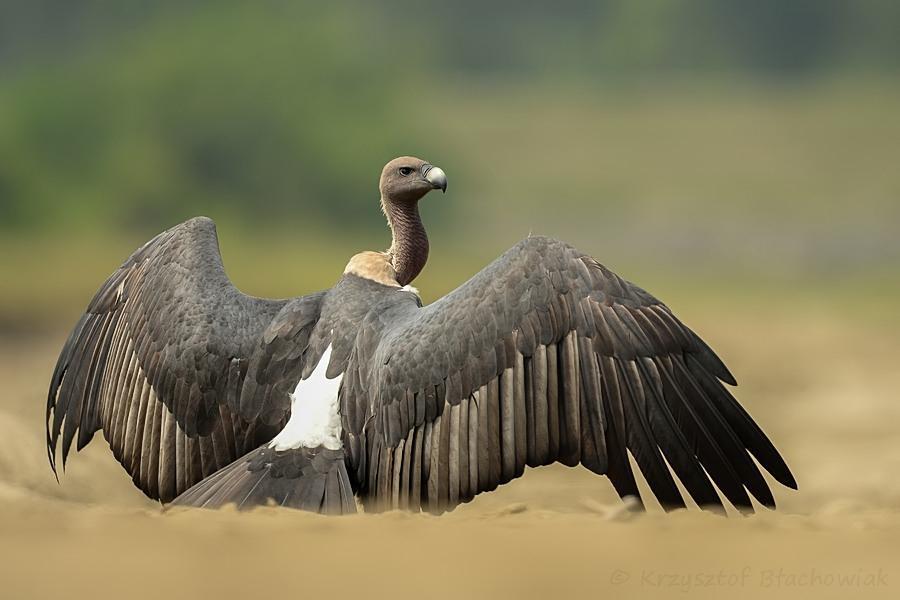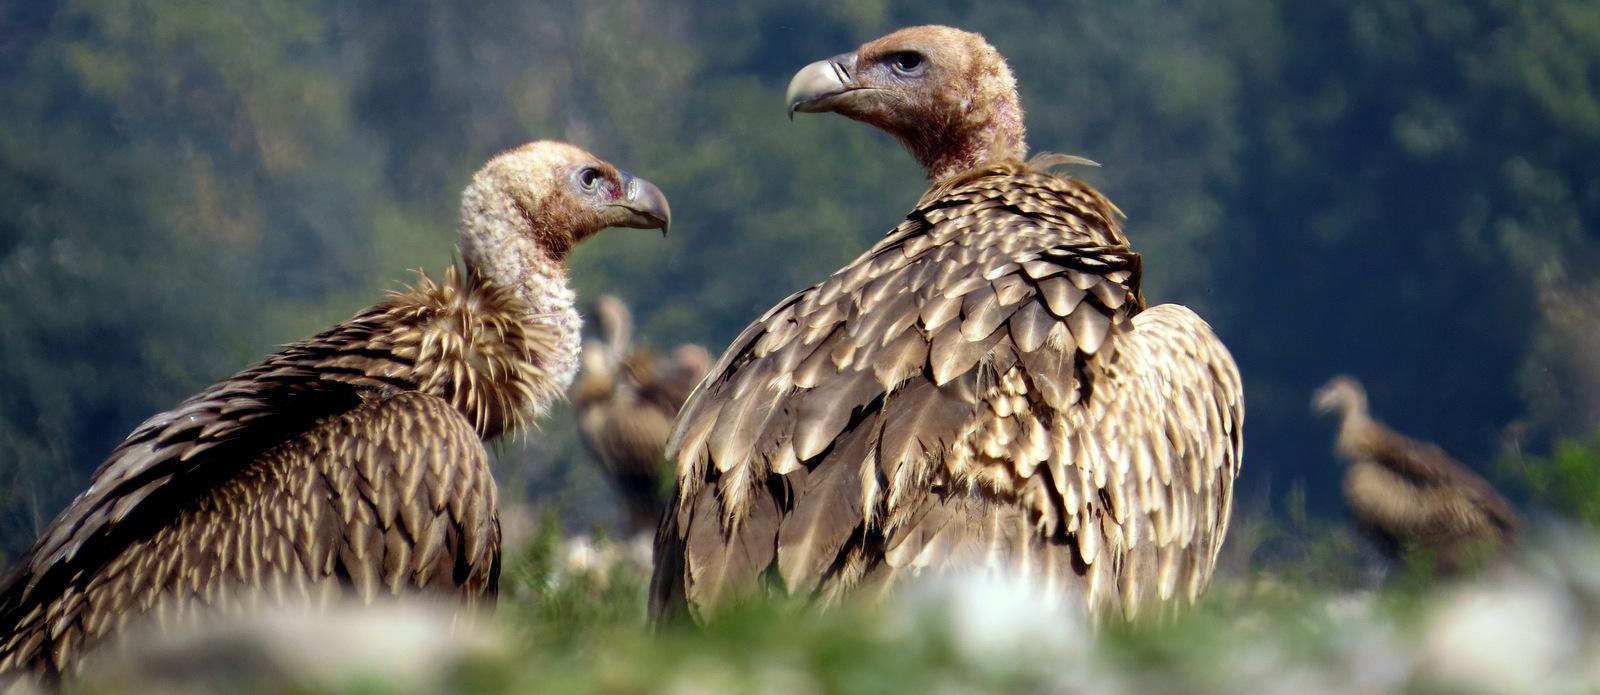The first image is the image on the left, the second image is the image on the right. Analyze the images presented: Is the assertion "The bird in the left image is looking towards the left." valid? Answer yes or no. No. The first image is the image on the left, the second image is the image on the right. For the images displayed, is the sentence "An image shows one vulture with outspread wings, but it is not in flight off the ground." factually correct? Answer yes or no. Yes. 